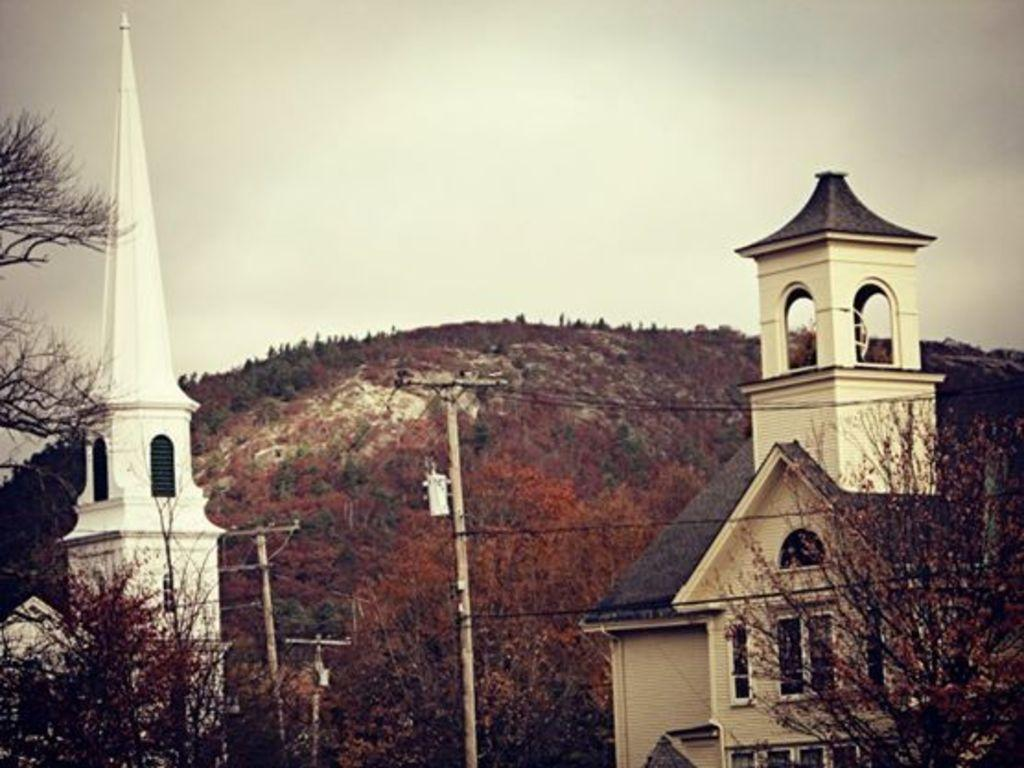What type of structures can be seen in the image? There are buildings in the image. What natural features are present in the image? There are hills in the image. What man-made objects can be seen in the image? There are electric poles and electric cables in the image. What type of vegetation is present in the image? There are trees in the image. What part of the natural environment is visible in the image? The sky is visible in the image. What type of bird is sitting on the yak in the image? There is no bird or yak present in the image. What does the caption say about the image? There is no caption provided with the image. 